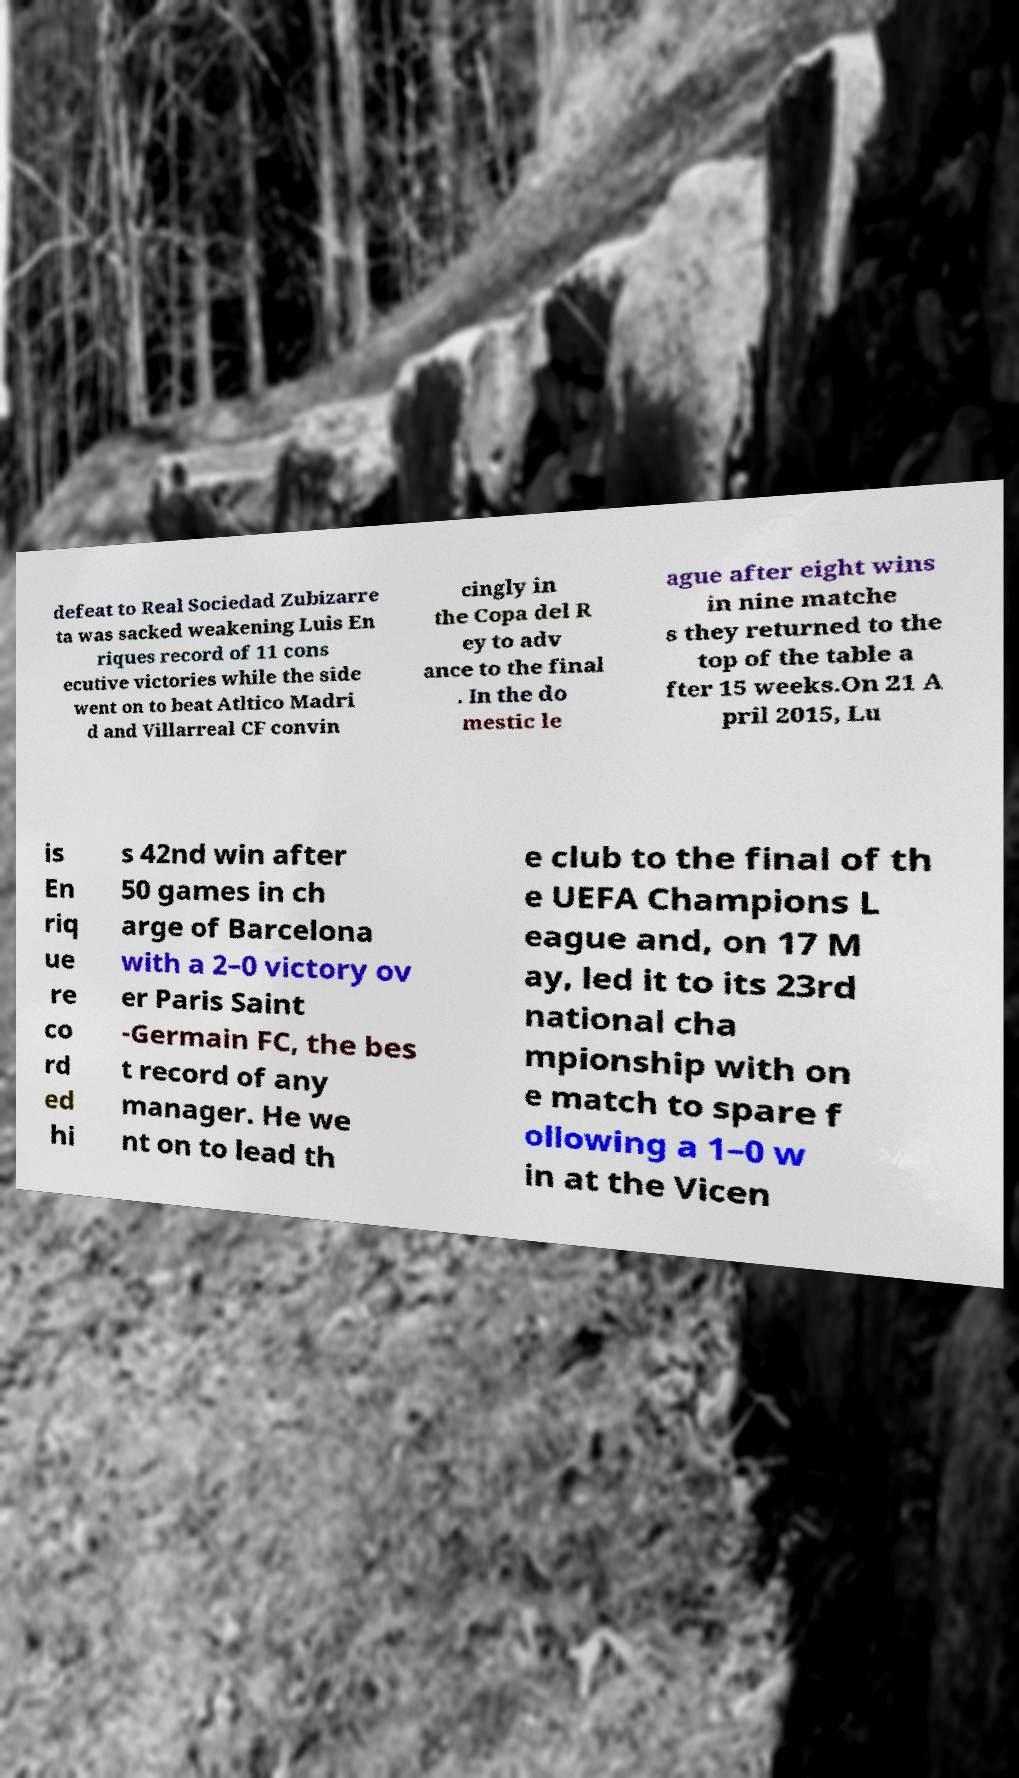Can you read and provide the text displayed in the image?This photo seems to have some interesting text. Can you extract and type it out for me? defeat to Real Sociedad Zubizarre ta was sacked weakening Luis En riques record of 11 cons ecutive victories while the side went on to beat Atltico Madri d and Villarreal CF convin cingly in the Copa del R ey to adv ance to the final . In the do mestic le ague after eight wins in nine matche s they returned to the top of the table a fter 15 weeks.On 21 A pril 2015, Lu is En riq ue re co rd ed hi s 42nd win after 50 games in ch arge of Barcelona with a 2–0 victory ov er Paris Saint -Germain FC, the bes t record of any manager. He we nt on to lead th e club to the final of th e UEFA Champions L eague and, on 17 M ay, led it to its 23rd national cha mpionship with on e match to spare f ollowing a 1–0 w in at the Vicen 